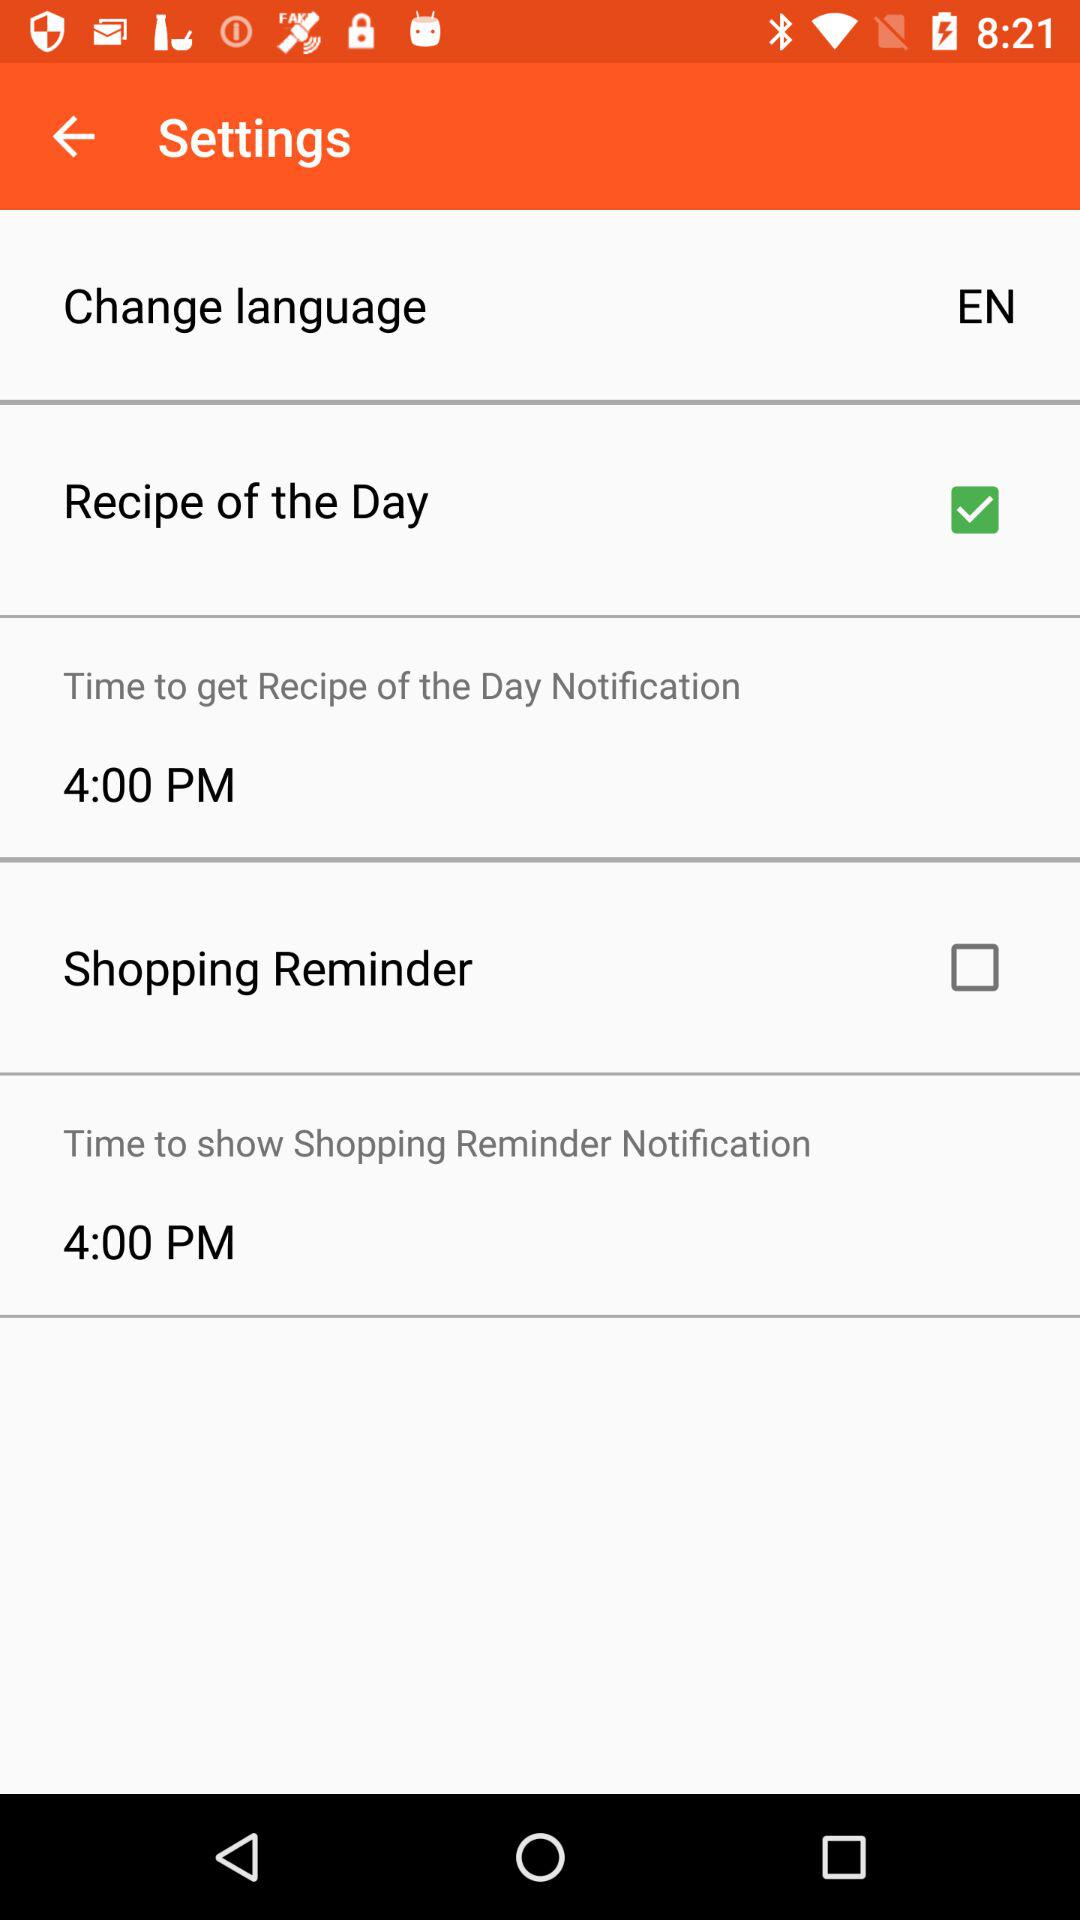What's the time to get the recipe of the day notification? The time to get the recipe of the day notification is 4:00 PM. 